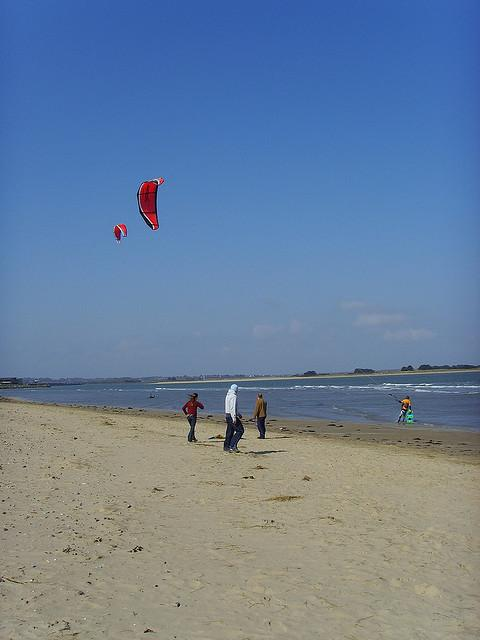What touches the feet of the people holding the airborn sails? sand 